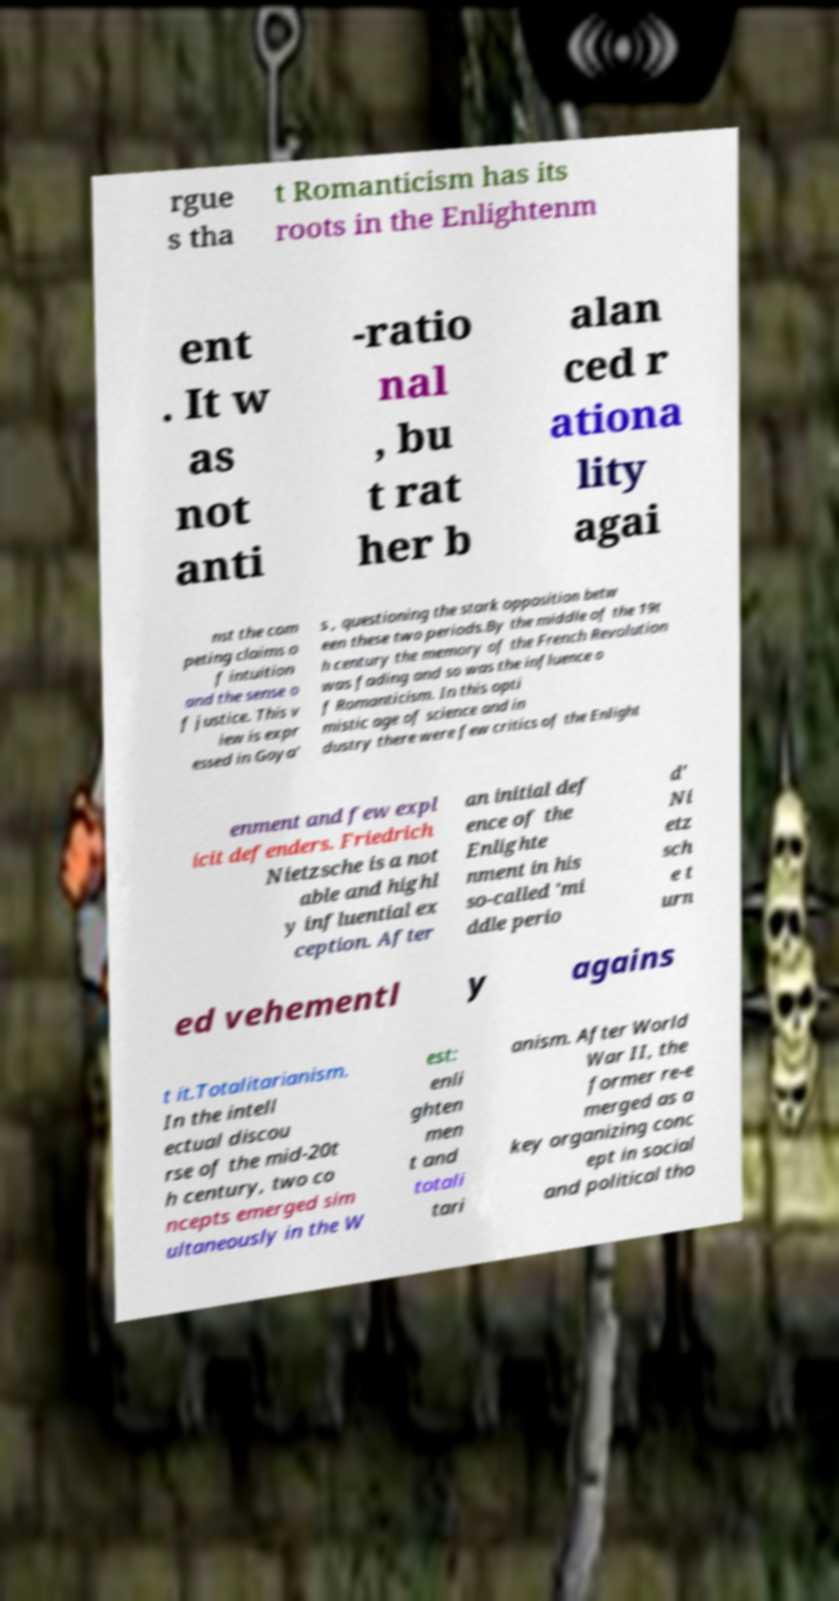What messages or text are displayed in this image? I need them in a readable, typed format. rgue s tha t Romanticism has its roots in the Enlightenm ent . It w as not anti -ratio nal , bu t rat her b alan ced r ationa lity agai nst the com peting claims o f intuition and the sense o f justice. This v iew is expr essed in Goya' s , questioning the stark opposition betw een these two periods.By the middle of the 19t h century the memory of the French Revolution was fading and so was the influence o f Romanticism. In this opti mistic age of science and in dustry there were few critics of the Enlight enment and few expl icit defenders. Friedrich Nietzsche is a not able and highl y influential ex ception. After an initial def ence of the Enlighte nment in his so-called 'mi ddle perio d' Ni etz sch e t urn ed vehementl y agains t it.Totalitarianism. In the intell ectual discou rse of the mid-20t h century, two co ncepts emerged sim ultaneously in the W est: enli ghten men t and totali tari anism. After World War II, the former re-e merged as a key organizing conc ept in social and political tho 